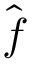<formula> <loc_0><loc_0><loc_500><loc_500>\hat { f }</formula> 